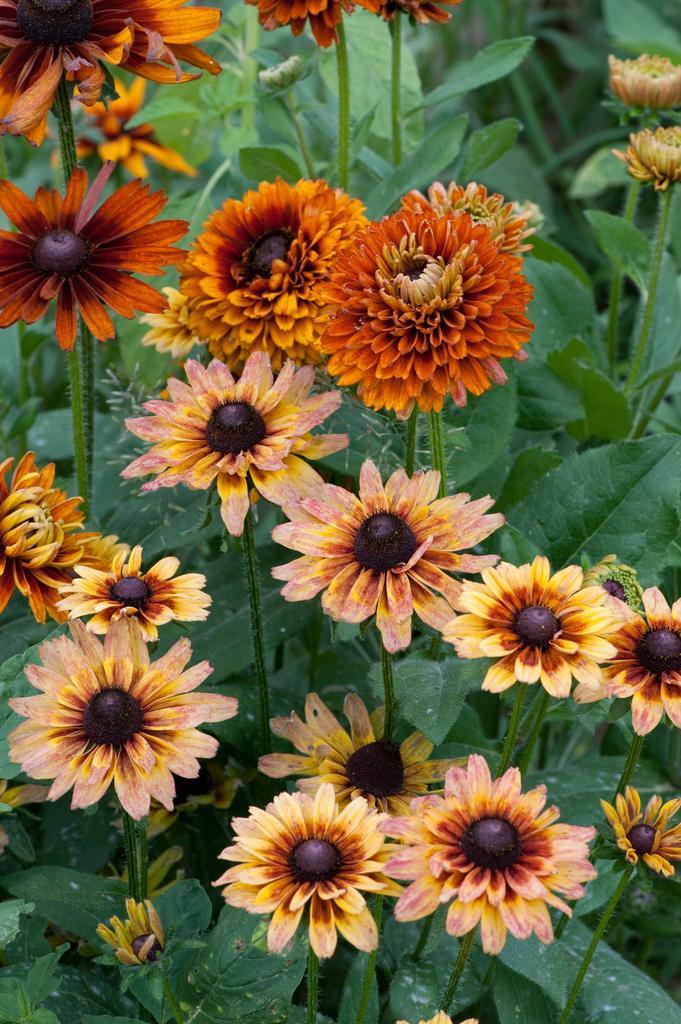Can you describe this image briefly? In this picture we can see a group of flowers and in the background we can see leaves. 